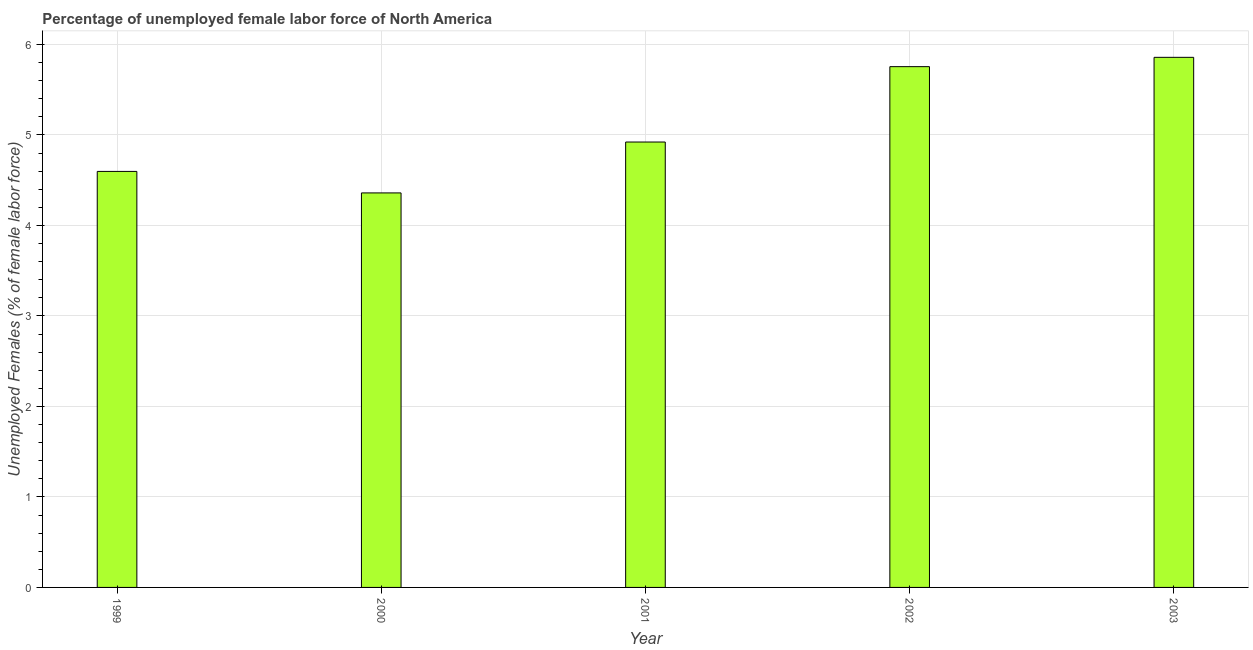Does the graph contain any zero values?
Offer a very short reply. No. What is the title of the graph?
Offer a terse response. Percentage of unemployed female labor force of North America. What is the label or title of the Y-axis?
Offer a very short reply. Unemployed Females (% of female labor force). What is the total unemployed female labour force in 2000?
Keep it short and to the point. 4.36. Across all years, what is the maximum total unemployed female labour force?
Provide a short and direct response. 5.86. Across all years, what is the minimum total unemployed female labour force?
Offer a terse response. 4.36. What is the sum of the total unemployed female labour force?
Keep it short and to the point. 25.49. What is the difference between the total unemployed female labour force in 2000 and 2003?
Provide a short and direct response. -1.5. What is the average total unemployed female labour force per year?
Ensure brevity in your answer.  5.1. What is the median total unemployed female labour force?
Make the answer very short. 4.92. What is the ratio of the total unemployed female labour force in 1999 to that in 2001?
Ensure brevity in your answer.  0.93. Is the total unemployed female labour force in 1999 less than that in 2001?
Keep it short and to the point. Yes. What is the difference between the highest and the second highest total unemployed female labour force?
Your response must be concise. 0.1. Is the sum of the total unemployed female labour force in 1999 and 2002 greater than the maximum total unemployed female labour force across all years?
Offer a very short reply. Yes. What is the difference between the highest and the lowest total unemployed female labour force?
Ensure brevity in your answer.  1.5. In how many years, is the total unemployed female labour force greater than the average total unemployed female labour force taken over all years?
Provide a succinct answer. 2. What is the Unemployed Females (% of female labor force) of 1999?
Give a very brief answer. 4.6. What is the Unemployed Females (% of female labor force) of 2000?
Give a very brief answer. 4.36. What is the Unemployed Females (% of female labor force) in 2001?
Provide a short and direct response. 4.92. What is the Unemployed Females (% of female labor force) of 2002?
Your answer should be compact. 5.75. What is the Unemployed Females (% of female labor force) in 2003?
Provide a short and direct response. 5.86. What is the difference between the Unemployed Females (% of female labor force) in 1999 and 2000?
Your answer should be compact. 0.24. What is the difference between the Unemployed Females (% of female labor force) in 1999 and 2001?
Offer a terse response. -0.32. What is the difference between the Unemployed Females (% of female labor force) in 1999 and 2002?
Make the answer very short. -1.16. What is the difference between the Unemployed Females (% of female labor force) in 1999 and 2003?
Offer a very short reply. -1.26. What is the difference between the Unemployed Females (% of female labor force) in 2000 and 2001?
Provide a succinct answer. -0.56. What is the difference between the Unemployed Females (% of female labor force) in 2000 and 2002?
Ensure brevity in your answer.  -1.4. What is the difference between the Unemployed Females (% of female labor force) in 2000 and 2003?
Give a very brief answer. -1.5. What is the difference between the Unemployed Females (% of female labor force) in 2001 and 2002?
Ensure brevity in your answer.  -0.83. What is the difference between the Unemployed Females (% of female labor force) in 2001 and 2003?
Give a very brief answer. -0.94. What is the difference between the Unemployed Females (% of female labor force) in 2002 and 2003?
Your answer should be compact. -0.1. What is the ratio of the Unemployed Females (% of female labor force) in 1999 to that in 2000?
Provide a succinct answer. 1.05. What is the ratio of the Unemployed Females (% of female labor force) in 1999 to that in 2001?
Your answer should be very brief. 0.93. What is the ratio of the Unemployed Females (% of female labor force) in 1999 to that in 2002?
Keep it short and to the point. 0.8. What is the ratio of the Unemployed Females (% of female labor force) in 1999 to that in 2003?
Keep it short and to the point. 0.79. What is the ratio of the Unemployed Females (% of female labor force) in 2000 to that in 2001?
Provide a succinct answer. 0.89. What is the ratio of the Unemployed Females (% of female labor force) in 2000 to that in 2002?
Your response must be concise. 0.76. What is the ratio of the Unemployed Females (% of female labor force) in 2000 to that in 2003?
Make the answer very short. 0.74. What is the ratio of the Unemployed Females (% of female labor force) in 2001 to that in 2002?
Ensure brevity in your answer.  0.85. What is the ratio of the Unemployed Females (% of female labor force) in 2001 to that in 2003?
Your answer should be compact. 0.84. 